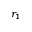<formula> <loc_0><loc_0><loc_500><loc_500>r _ { 1 }</formula> 